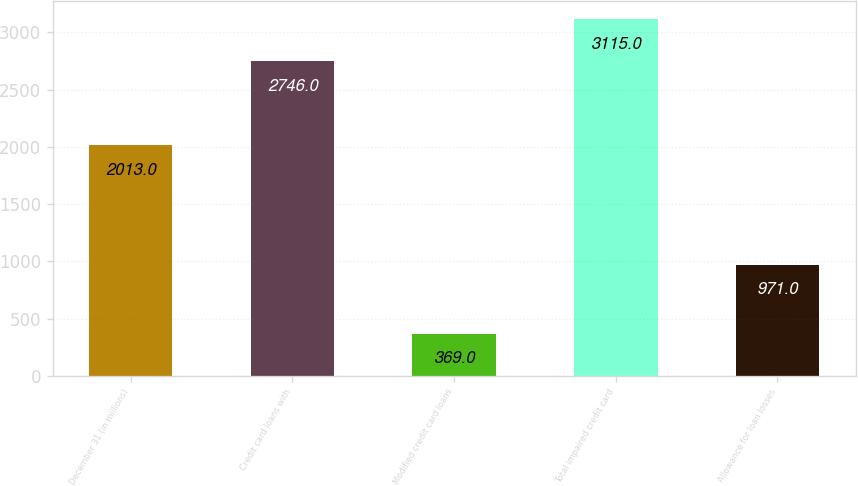Convert chart. <chart><loc_0><loc_0><loc_500><loc_500><bar_chart><fcel>December 31 (in millions)<fcel>Credit card loans with<fcel>Modified credit card loans<fcel>Total impaired credit card<fcel>Allowance for loan losses<nl><fcel>2013<fcel>2746<fcel>369<fcel>3115<fcel>971<nl></chart> 